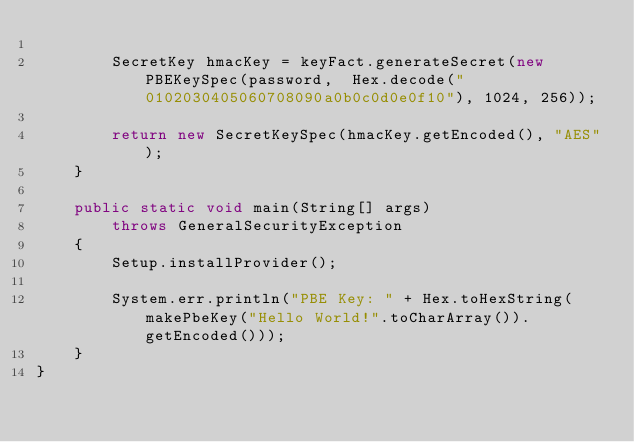Convert code to text. <code><loc_0><loc_0><loc_500><loc_500><_Java_>
        SecretKey hmacKey = keyFact.generateSecret(new PBEKeySpec(password,  Hex.decode("0102030405060708090a0b0c0d0e0f10"), 1024, 256));

        return new SecretKeySpec(hmacKey.getEncoded(), "AES");
    }

    public static void main(String[] args)
        throws GeneralSecurityException
    {
        Setup.installProvider();

        System.err.println("PBE Key: " + Hex.toHexString(makePbeKey("Hello World!".toCharArray()).getEncoded()));
    }
}
</code> 